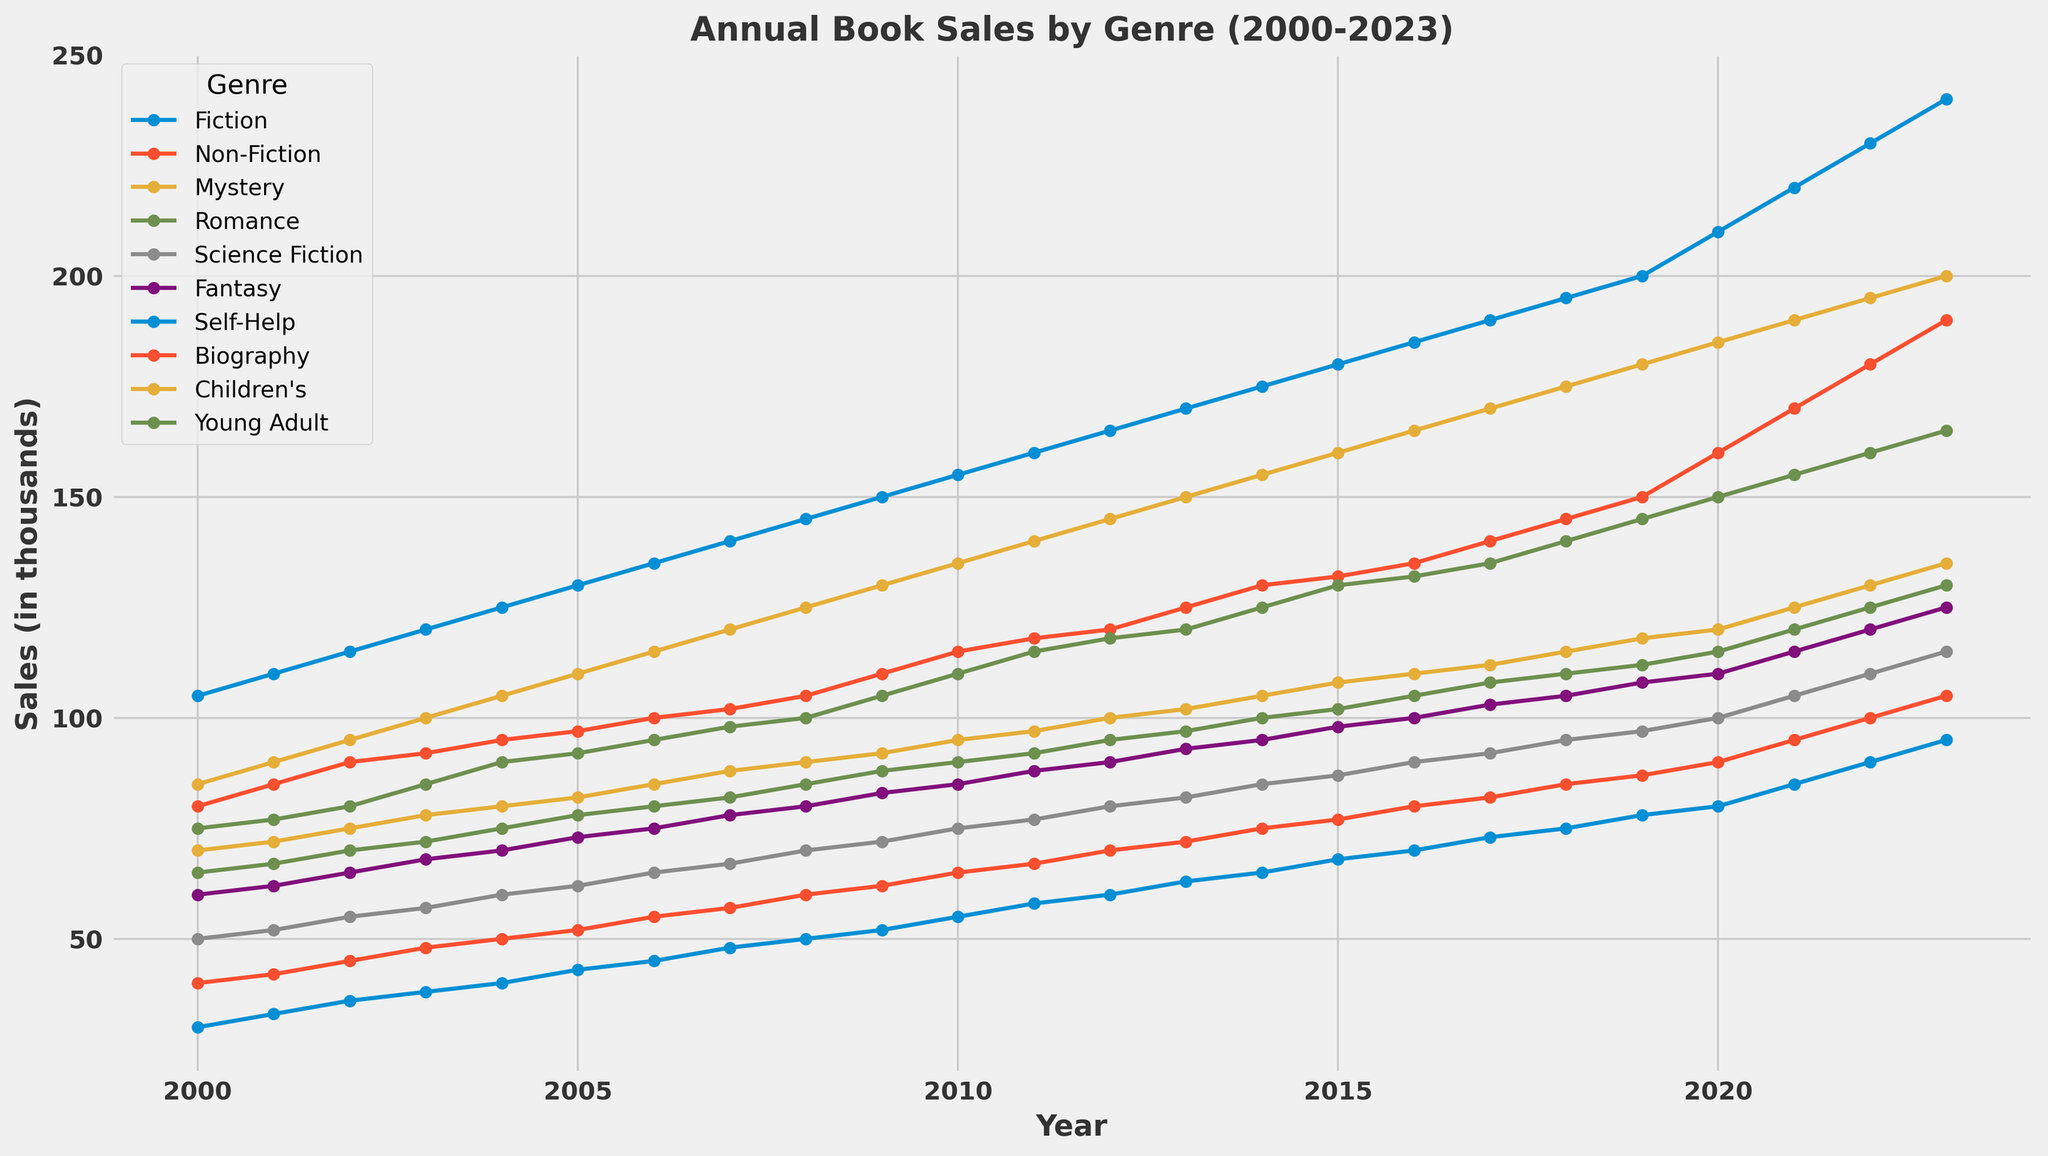What's the difference in book sales between Fiction and Non-Fiction in 2023? To find the difference, subtract the Non-Fiction sales from the Fiction sales for the year 2023. Fiction sales in 2023 are 240, and Non-Fiction sales in 2023 are 190. Hence, the difference is 240 - 190 = 50.
Answer: 50 What is the total sales for Children's and Young Adult genres in 2015? Add the sales values for both genres in the year 2015. Children's sales are 160, and Young Adult sales are 130. Therefore, the total sales are 160 + 130 = 290.
Answer: 290 Which genre had the highest sales in 2021 and what were the sales figures? By observing the chart for the year 2021, the highest sales were in the Fiction genre with a sales figure of 220.
Answer: Fiction, 220 What is the average increase in book sales for the Fantasy genre from 2000 to 2023? To find the average increase, subtract the 2000 sales from the 2023 sales and then divide by the number of years. The sales in 2000 were 60, and in 2023 were 125. The number of years is 2023 - 2000 = 23. The average increase is (125 - 60) / 23 ≈ 2.83.
Answer: 2.83 Which genre showed the most significant growth over the entire period from 2000 to 2023? To determine this, compare the sales figures from 2000 and 2023 for each genre and identify the one with the largest increase. Fiction grew from 105 to 240, which is an increase of 135, and this is the largest increase among all genres.
Answer: Fiction In which year did Mystery and Science Fiction sales both reach 100, and what is the significance of that year? By analyzing the data, both Mystery and Science Fiction sales reached 100 in the year 2014. This year is significant as it's the point when both genres align at the same sales figure of 100.
Answer: 2014 What is the cumulative sales for Romance from 2000 to 2010? Sum the sales figures for Romance from 2000 to 2010 inclusive. Adding these values: 65 + 67 + 70 + 72 + 75 + 78 + 80 + 82 + 85 + 88 + 90 = 852.
Answer: 852 What year did the Biography genre surpass 100 in sales? Check each year's sales figures for Biography and find the earliest year it exceeds 100. In 2017, the Biography genre sales were 105.
Answer: 2017 Which two genres had the closest sales figures in 2005 and what were the figures? By observing the chart for 2005, Mystery and Romance genres had sales figures of 82 and 78, respectively, which are the closest for that year with a difference of 4.
Answer: Mystery (82) and Romance (78) What is the visual trend for the Self-Help genre from 2015 to 2023? The Self-Help genre shows an upward trend in sales from 2015 to 2023 as observed in the chart. Sales figures grow from 68 to 95, displaying a consistent yearly increase.
Answer: Upward trend 